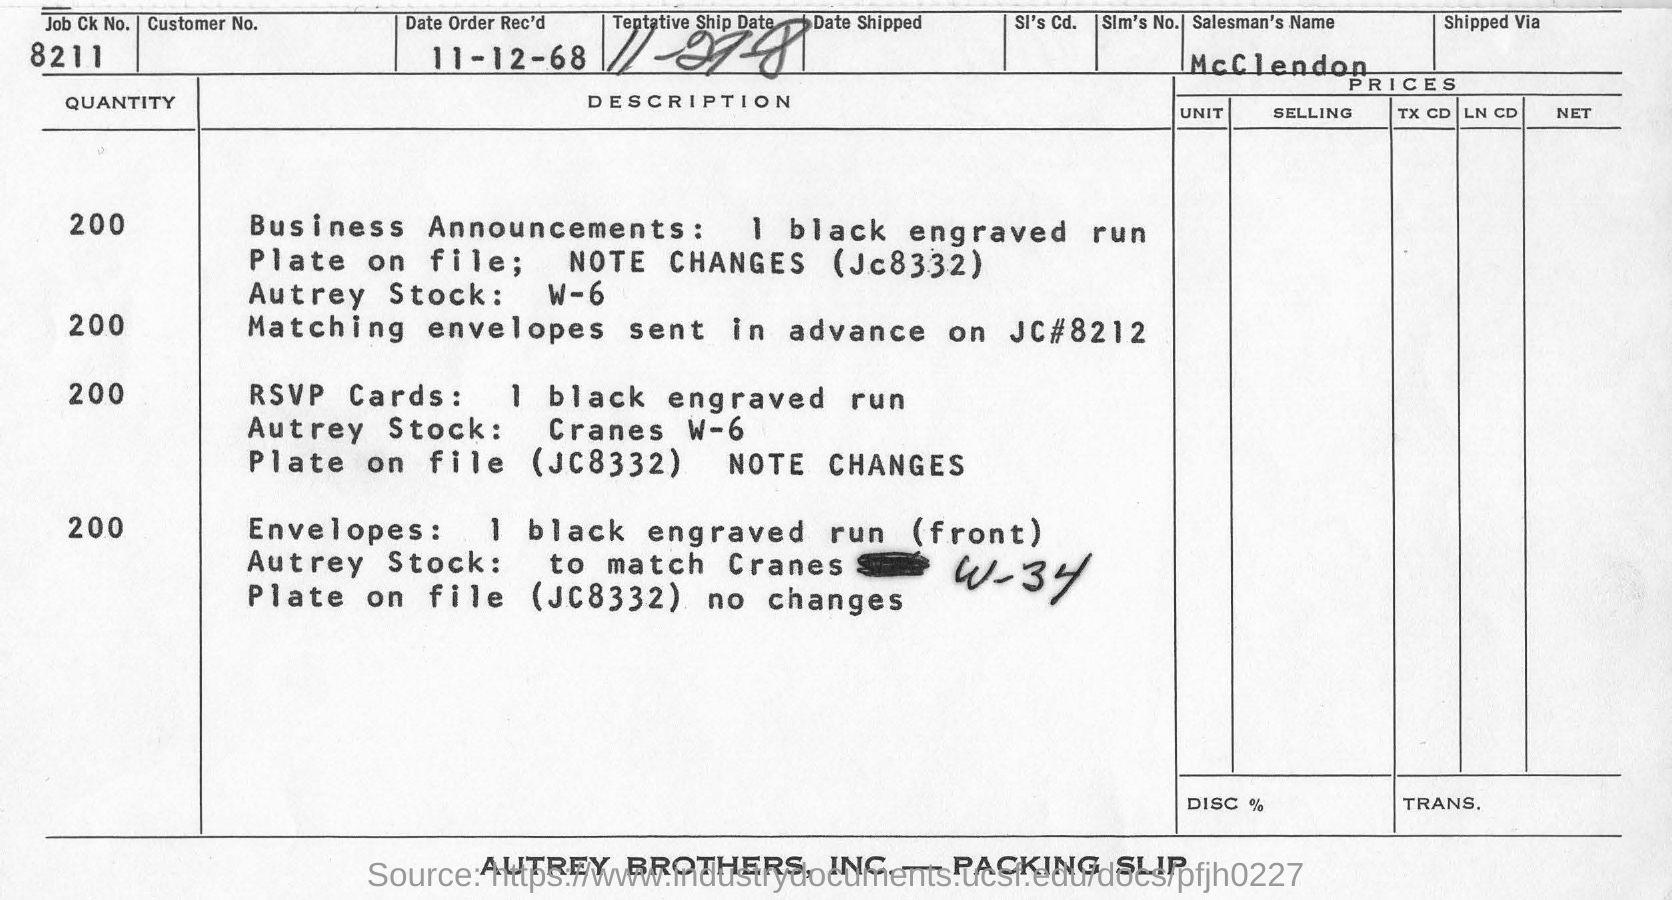What is the name of the Salesman?
Offer a terse response. McClendon. What is the job Ck No.?
Offer a very short reply. 8211. What is the date of order received?
Make the answer very short. 11-12-68. 